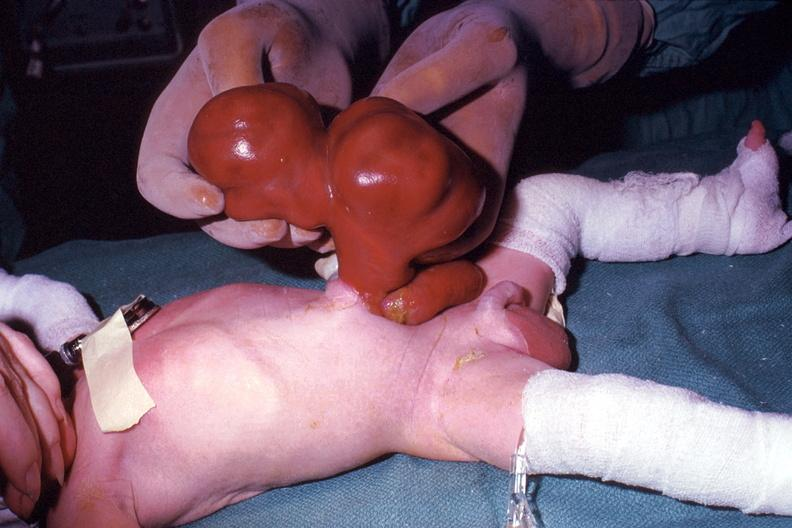when does this image show a photo taken?
Answer the question using a single word or phrase. During life large lesion 